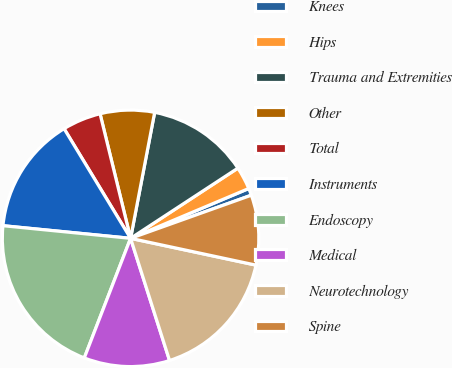Convert chart. <chart><loc_0><loc_0><loc_500><loc_500><pie_chart><fcel>Knees<fcel>Hips<fcel>Trauma and Extremities<fcel>Other<fcel>Total<fcel>Instruments<fcel>Endoscopy<fcel>Medical<fcel>Neurotechnology<fcel>Spine<nl><fcel>0.89%<fcel>2.87%<fcel>12.77%<fcel>6.83%<fcel>4.85%<fcel>14.75%<fcel>20.69%<fcel>10.79%<fcel>16.73%<fcel>8.81%<nl></chart> 